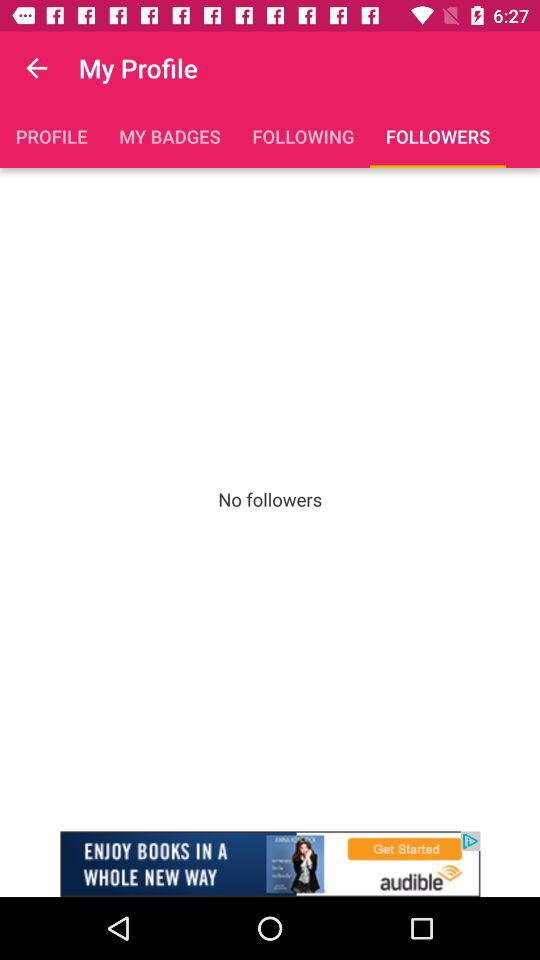How many followers does the user have?
Answer the question using a single word or phrase. 0 